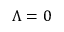<formula> <loc_0><loc_0><loc_500><loc_500>\Lambda = 0</formula> 